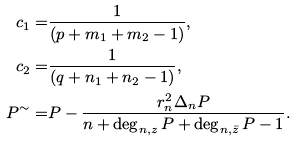Convert formula to latex. <formula><loc_0><loc_0><loc_500><loc_500>c _ { 1 } = & \frac { 1 } { ( p + m _ { 1 } + m _ { 2 } - 1 ) } , \\ c _ { 2 } = & \frac { 1 } { ( q + n _ { 1 } + n _ { 2 } - 1 ) } , \\ P ^ { \sim } = & P - \frac { r _ { n } ^ { 2 } \Delta _ { n } P } { n + \deg _ { n , z } P + \deg _ { n , \bar { z } } P - 1 } .</formula> 